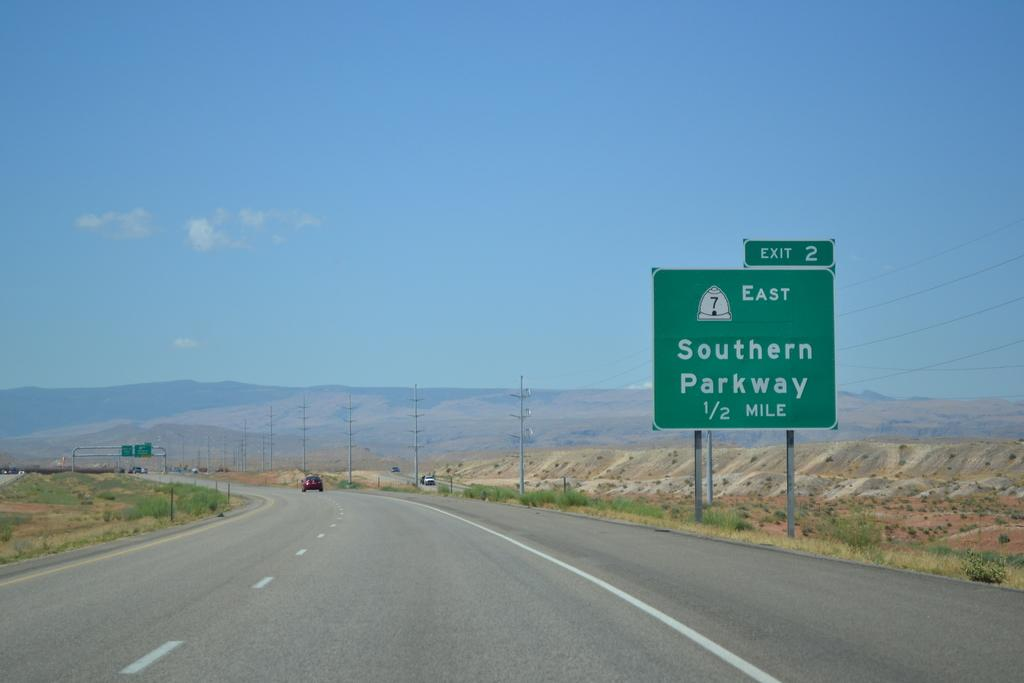<image>
Describe the image concisely. A large, green, sign on the highway informs drivers that the exit for Southern Parkway is in a half a mile. 